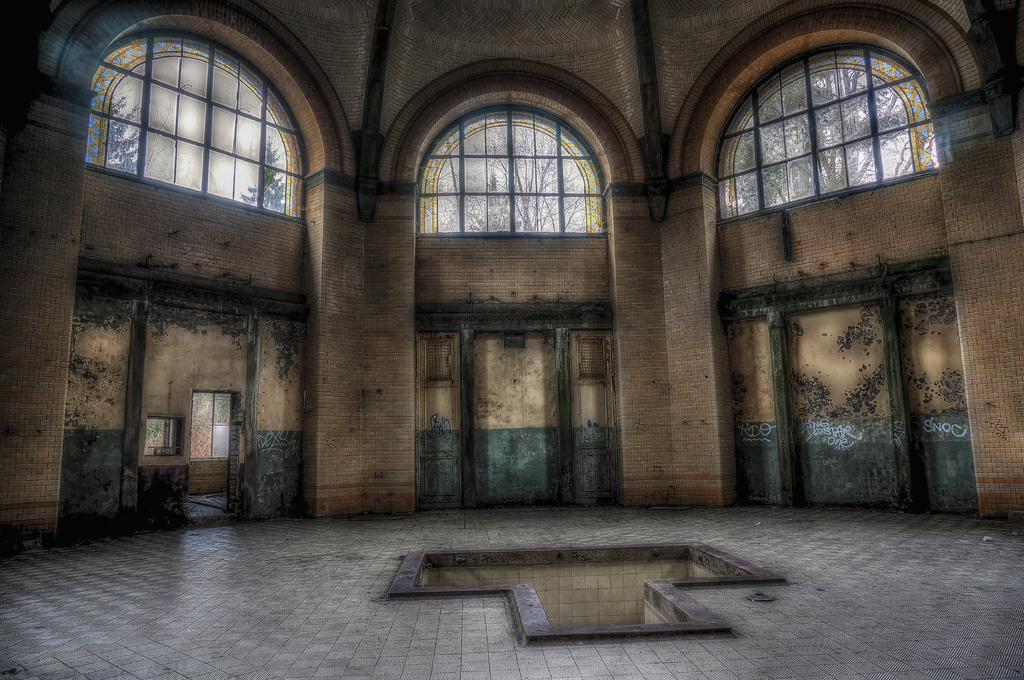What type of building is shown in the image? The image shows an inside view of a parish building. What architectural features can be seen in the parish building? There are doors and ventilators in the parish building. What can be seen through the ventilators? Trees are visible through the ventilators. What type of mint can be smelled in the image? There is no mention of mint or any smell in the image, so it cannot be determined from the image. 